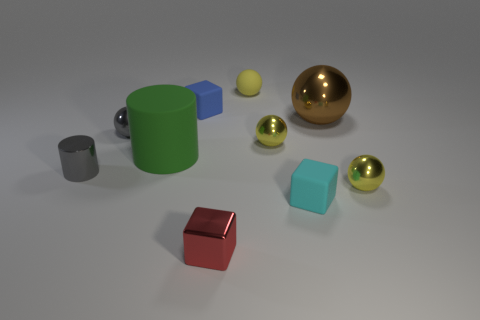Is the size of the block that is in front of the cyan rubber thing the same as the rubber cube that is behind the tiny cyan matte object?
Provide a short and direct response. Yes. How many other things are the same size as the brown ball?
Your answer should be compact. 1. There is a tiny yellow shiny sphere behind the small thing to the left of the tiny gray metallic ball; are there any big green matte things on the right side of it?
Offer a very short reply. No. Is there any other thing of the same color as the rubber sphere?
Your answer should be compact. Yes. How big is the thing in front of the cyan thing?
Your response must be concise. Small. There is a shiny ball to the right of the metallic thing that is behind the gray thing behind the shiny cylinder; what size is it?
Provide a succinct answer. Small. There is a tiny block that is behind the yellow object in front of the big matte thing; what color is it?
Provide a succinct answer. Blue. There is a tiny gray thing that is the same shape as the green rubber object; what is it made of?
Your answer should be very brief. Metal. Are there any other things that are made of the same material as the large green cylinder?
Provide a short and direct response. Yes. There is a red metallic cube; are there any gray shiny balls in front of it?
Provide a short and direct response. No. 